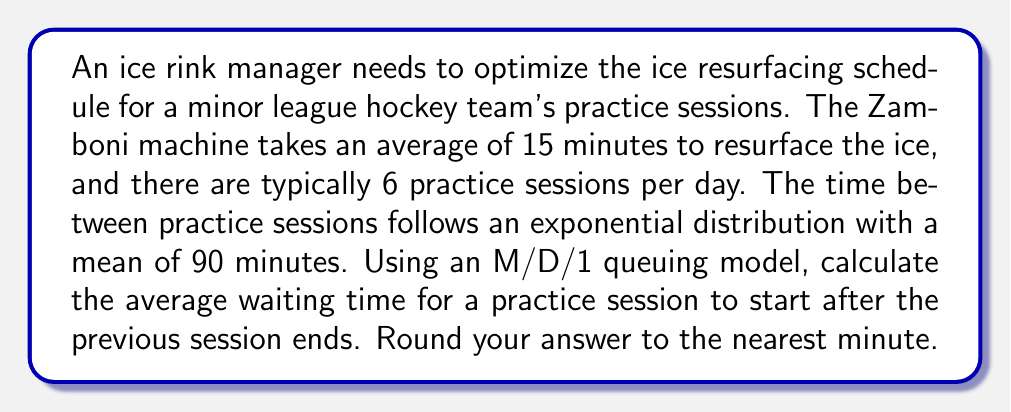Can you answer this question? To solve this problem, we'll use the M/D/1 queuing model, where:
M: Arrivals (practice sessions) follow a Poisson process
D: Service time (ice resurfacing) is deterministic
1: There is one server (Zamboni machine)

Step 1: Calculate the arrival rate (λ)
λ = 1 / mean time between arrivals
λ = 1 / 90 minutes = 1/90 per minute

Step 2: Calculate the service rate (μ)
μ = 1 / service time
μ = 1 / 15 minutes = 1/15 per minute

Step 3: Calculate the utilization factor (ρ)
ρ = λ / μ = (1/90) / (1/15) = 1/6 = 0.1667

Step 4: Use the M/D/1 waiting time formula
For an M/D/1 queue, the average waiting time (W_q) is given by:

$$ W_q = \frac{\rho^2}{2\lambda(1-\rho)} $$

Substituting the values:

$$ W_q = \frac{(0.1667)^2}{2(1/90)(1-0.1667)} $$

Step 5: Simplify and calculate
$$ W_q = \frac{0.0278}{2(1/90)(0.8333)} = \frac{0.0278 \times 90 \times 0.8333}{2} = 1.0416 \text{ minutes} $$

Step 6: Round to the nearest minute
1.0416 minutes ≈ 1 minute
Answer: 1 minute 